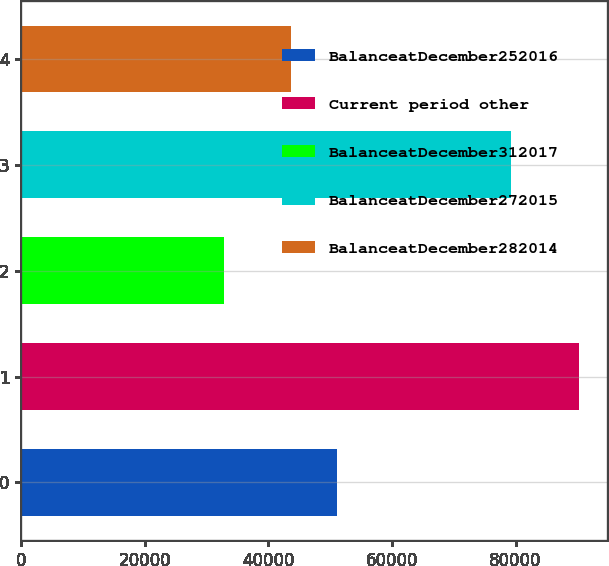Convert chart to OTSL. <chart><loc_0><loc_0><loc_500><loc_500><bar_chart><fcel>BalanceatDecember252016<fcel>Current period other<fcel>BalanceatDecember312017<fcel>BalanceatDecember272015<fcel>BalanceatDecember282014<nl><fcel>51085<fcel>90302<fcel>32827<fcel>79317<fcel>43689<nl></chart> 